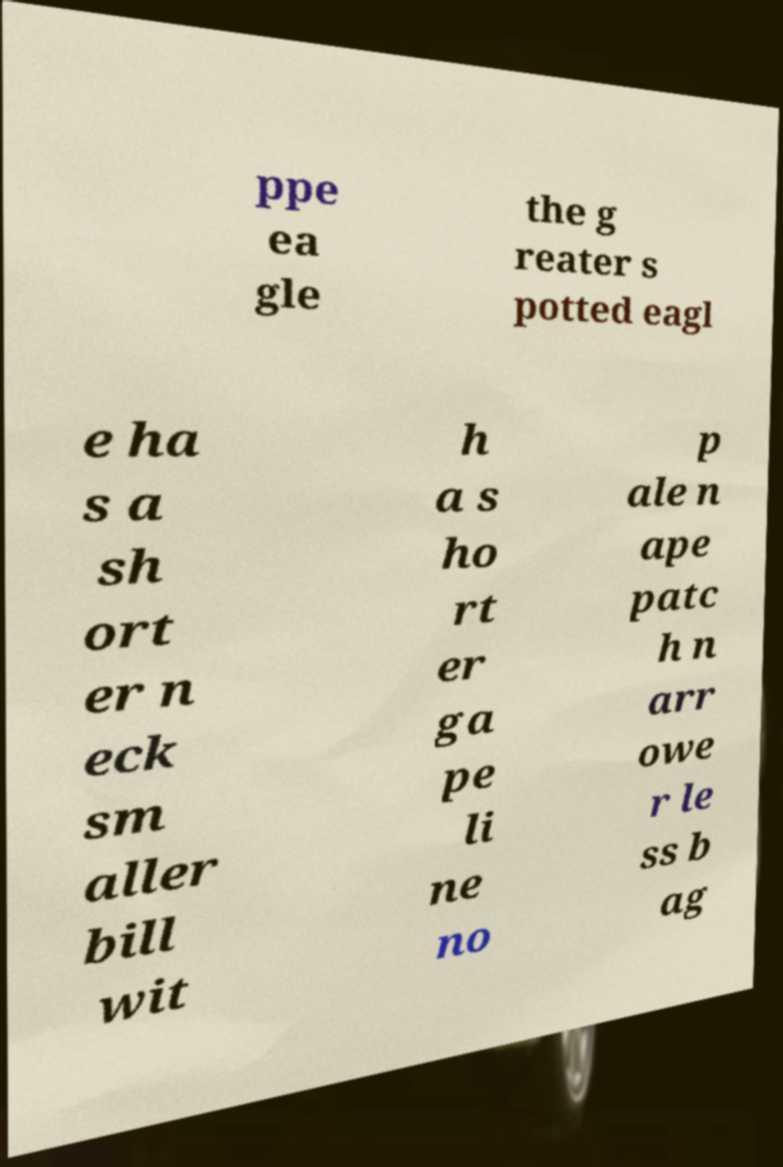For documentation purposes, I need the text within this image transcribed. Could you provide that? ppe ea gle the g reater s potted eagl e ha s a sh ort er n eck sm aller bill wit h a s ho rt er ga pe li ne no p ale n ape patc h n arr owe r le ss b ag 